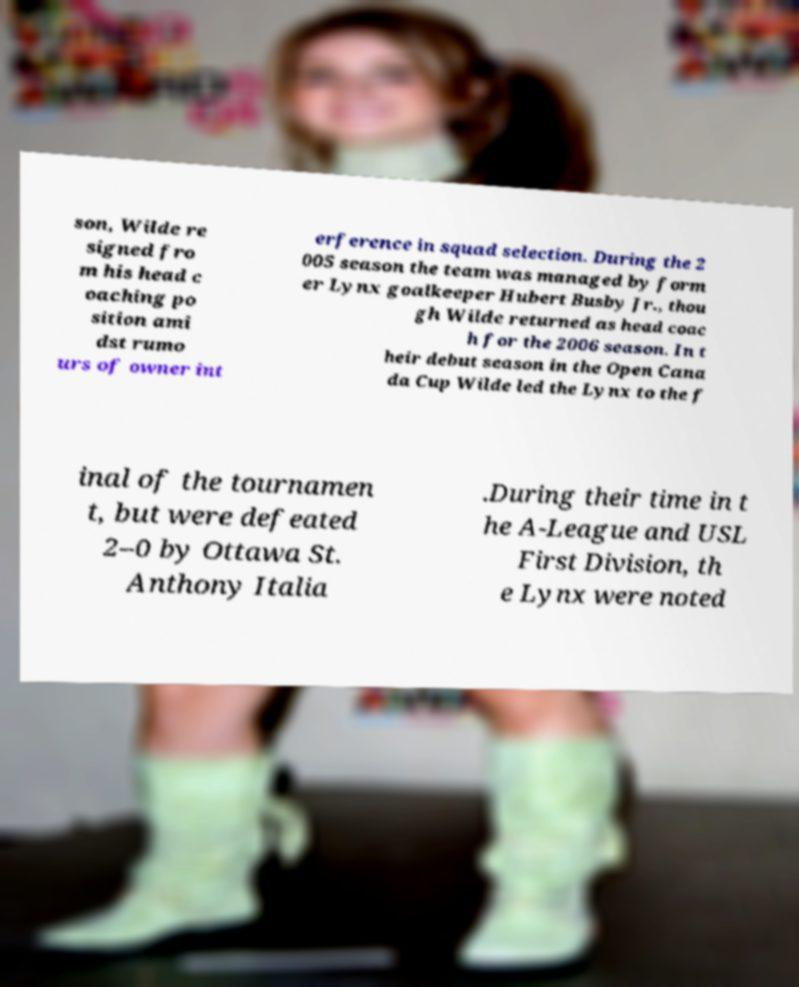What messages or text are displayed in this image? I need them in a readable, typed format. son, Wilde re signed fro m his head c oaching po sition ami dst rumo urs of owner int erference in squad selection. During the 2 005 season the team was managed by form er Lynx goalkeeper Hubert Busby Jr., thou gh Wilde returned as head coac h for the 2006 season. In t heir debut season in the Open Cana da Cup Wilde led the Lynx to the f inal of the tournamen t, but were defeated 2–0 by Ottawa St. Anthony Italia .During their time in t he A-League and USL First Division, th e Lynx were noted 